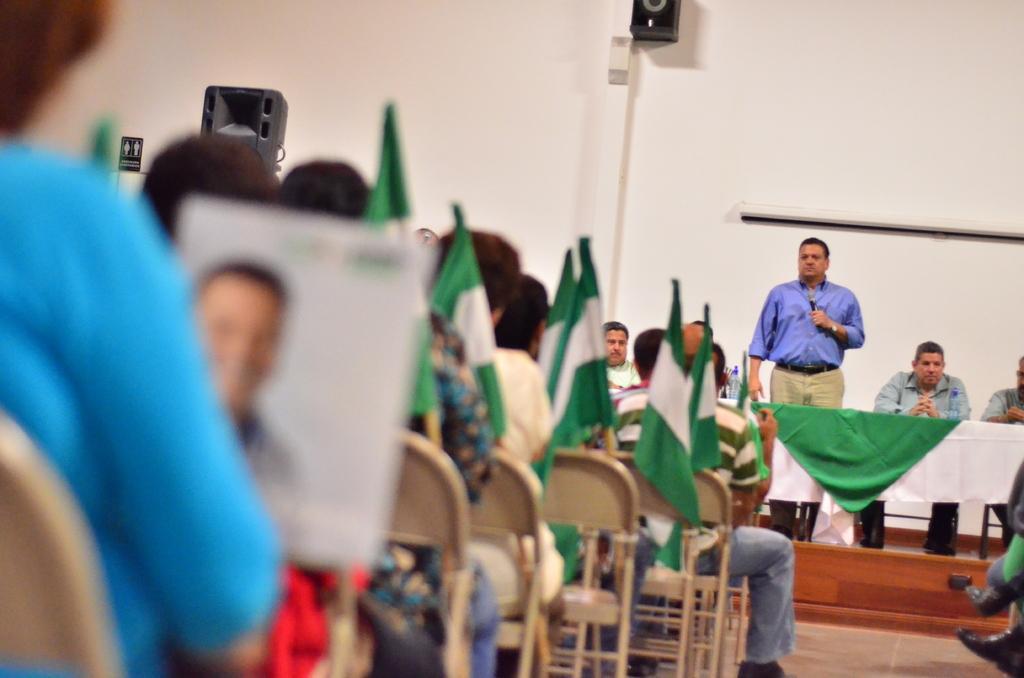How would you summarize this image in a sentence or two? In this image we can see people are sitting on the chairs. There is a man standing on the floor and he is holding a mike with his hand. Here we can see flags, poster, boards, and speaker. In the background we can see wall. 